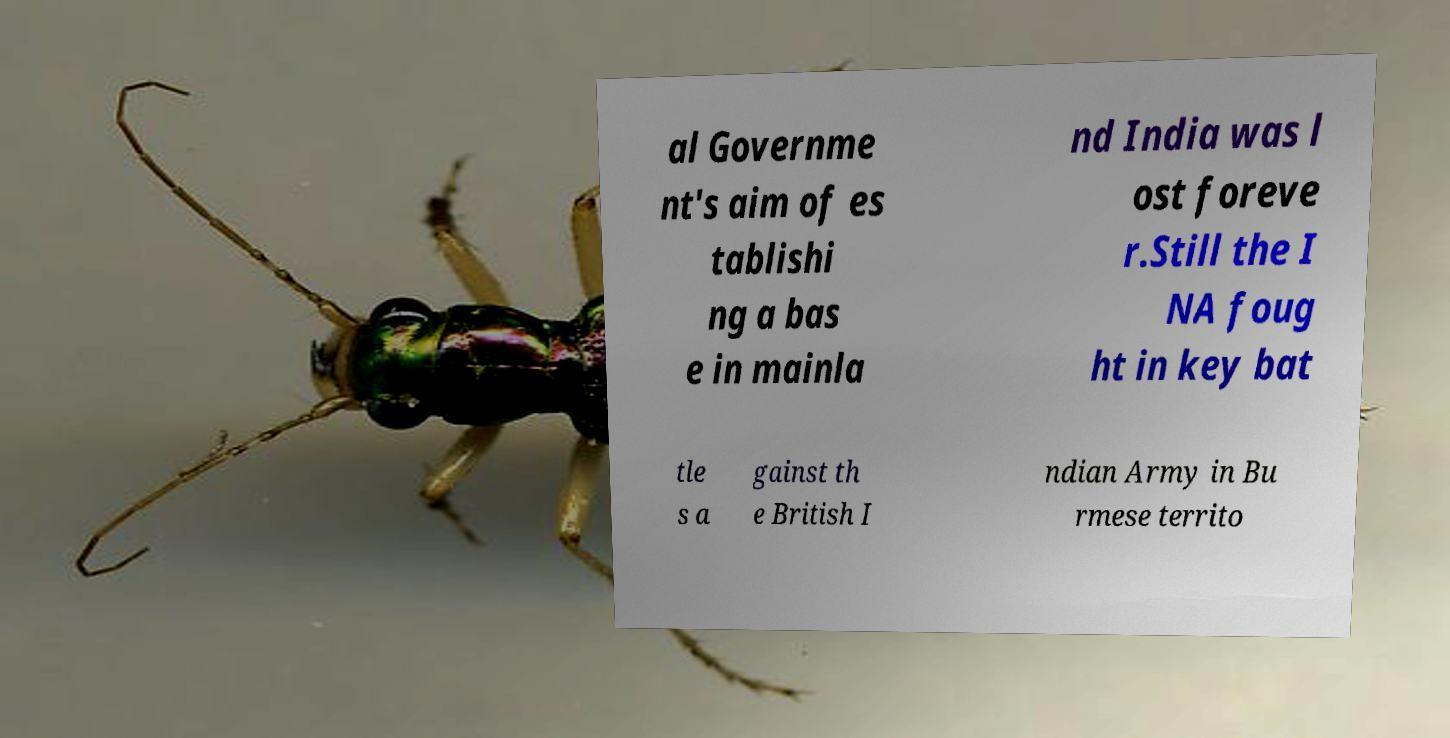Please read and relay the text visible in this image. What does it say? al Governme nt's aim of es tablishi ng a bas e in mainla nd India was l ost foreve r.Still the I NA foug ht in key bat tle s a gainst th e British I ndian Army in Bu rmese territo 